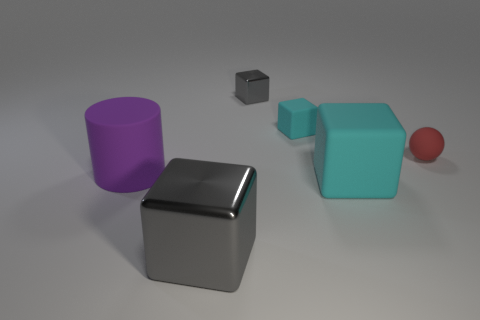What is the big purple object that is in front of the tiny cyan rubber thing made of?
Ensure brevity in your answer.  Rubber. Is there a big cyan rubber object that has the same shape as the purple matte thing?
Ensure brevity in your answer.  No. What number of other metallic objects are the same shape as the small metal object?
Provide a succinct answer. 1. Does the cyan rubber cube that is behind the large purple rubber cylinder have the same size as the object that is right of the large cyan matte object?
Your answer should be compact. Yes. There is a gray metallic thing that is right of the metallic cube that is in front of the sphere; what shape is it?
Keep it short and to the point. Cube. Are there an equal number of red matte balls that are in front of the small rubber ball and brown balls?
Your answer should be compact. Yes. What material is the small block right of the gray shiny thing behind the large purple cylinder in front of the small cyan matte cube made of?
Your response must be concise. Rubber. Is there a brown object that has the same size as the red rubber sphere?
Keep it short and to the point. No. There is a tiny cyan object; what shape is it?
Make the answer very short. Cube. What number of spheres are either large shiny objects or small red rubber objects?
Offer a very short reply. 1. 